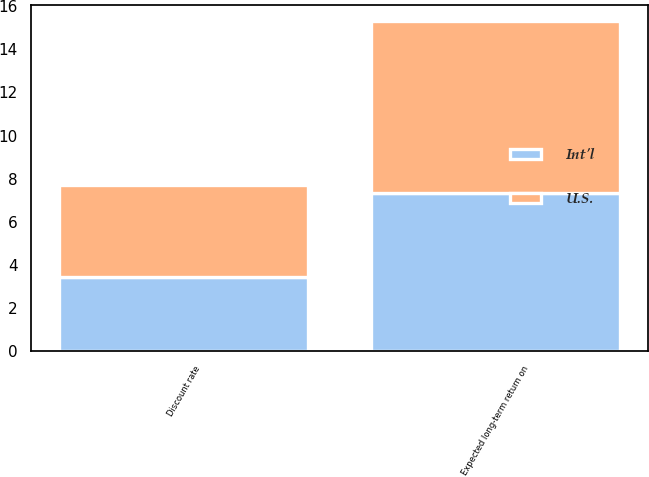<chart> <loc_0><loc_0><loc_500><loc_500><stacked_bar_chart><ecel><fcel>Discount rate<fcel>Expected long-term return on<nl><fcel>U.S.<fcel>4.27<fcel>8<nl><fcel>Int'l<fcel>3.44<fcel>7.31<nl></chart> 